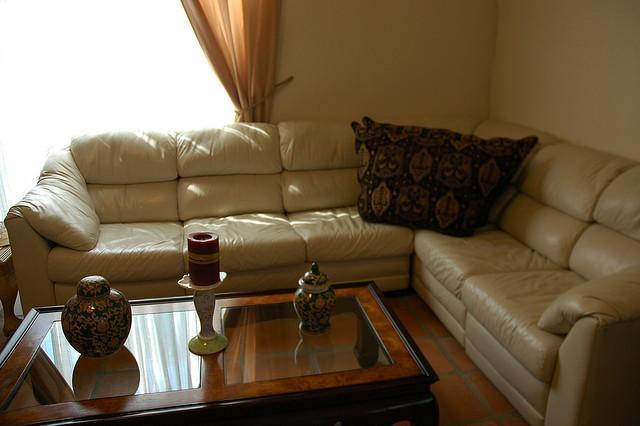How many couches are here?
Give a very brief answer. 1. How many pillows are on the couch?
Give a very brief answer. 2. How many vases are there?
Give a very brief answer. 2. How many chairs are in this picture?
Give a very brief answer. 0. 